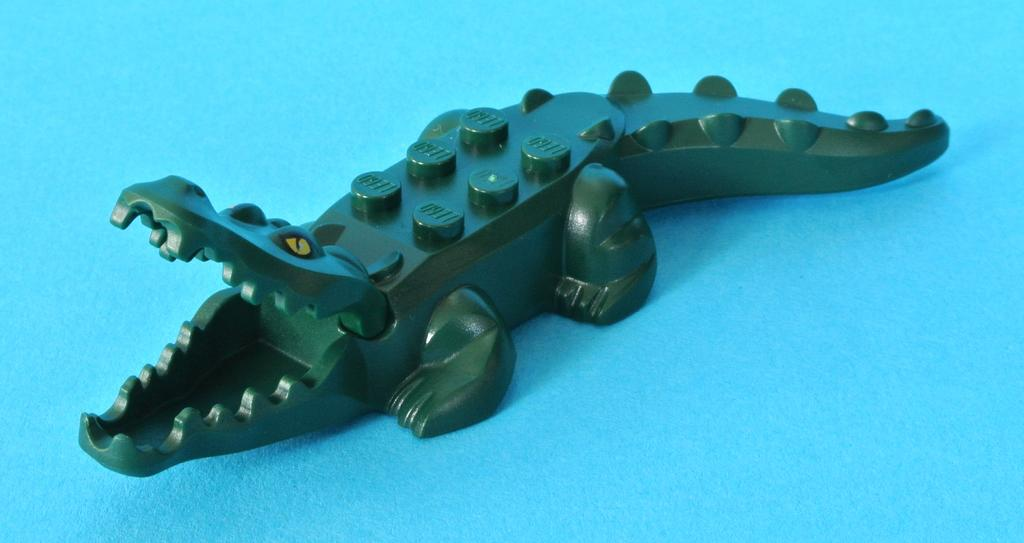What type of toy is present in the image? There is a toy crocodile in the image. What color is the toy crocodile? The toy crocodile is green in color. What is the toy crocodile placed on in the image? The toy crocodile is placed on a blue surface. How many crates are stacked next to the toy crocodile in the image? There are no crates present in the image. 